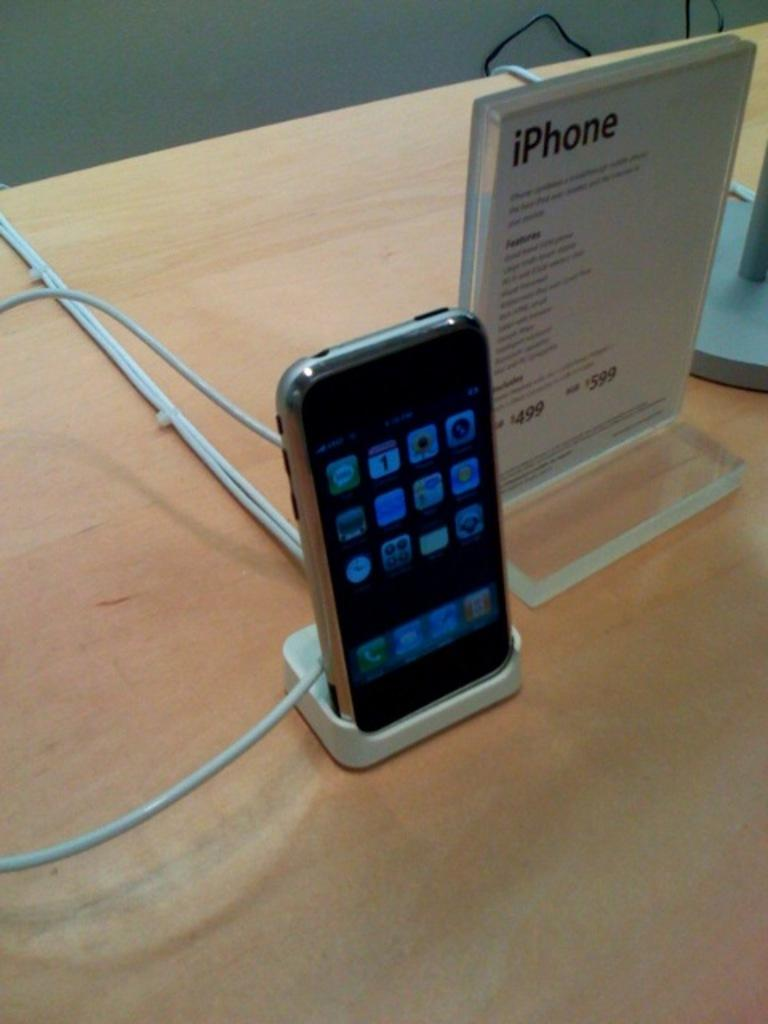Provide a one-sentence caption for the provided image. A cell phone sitting on a shelf with an sign saying IPhone on it. 